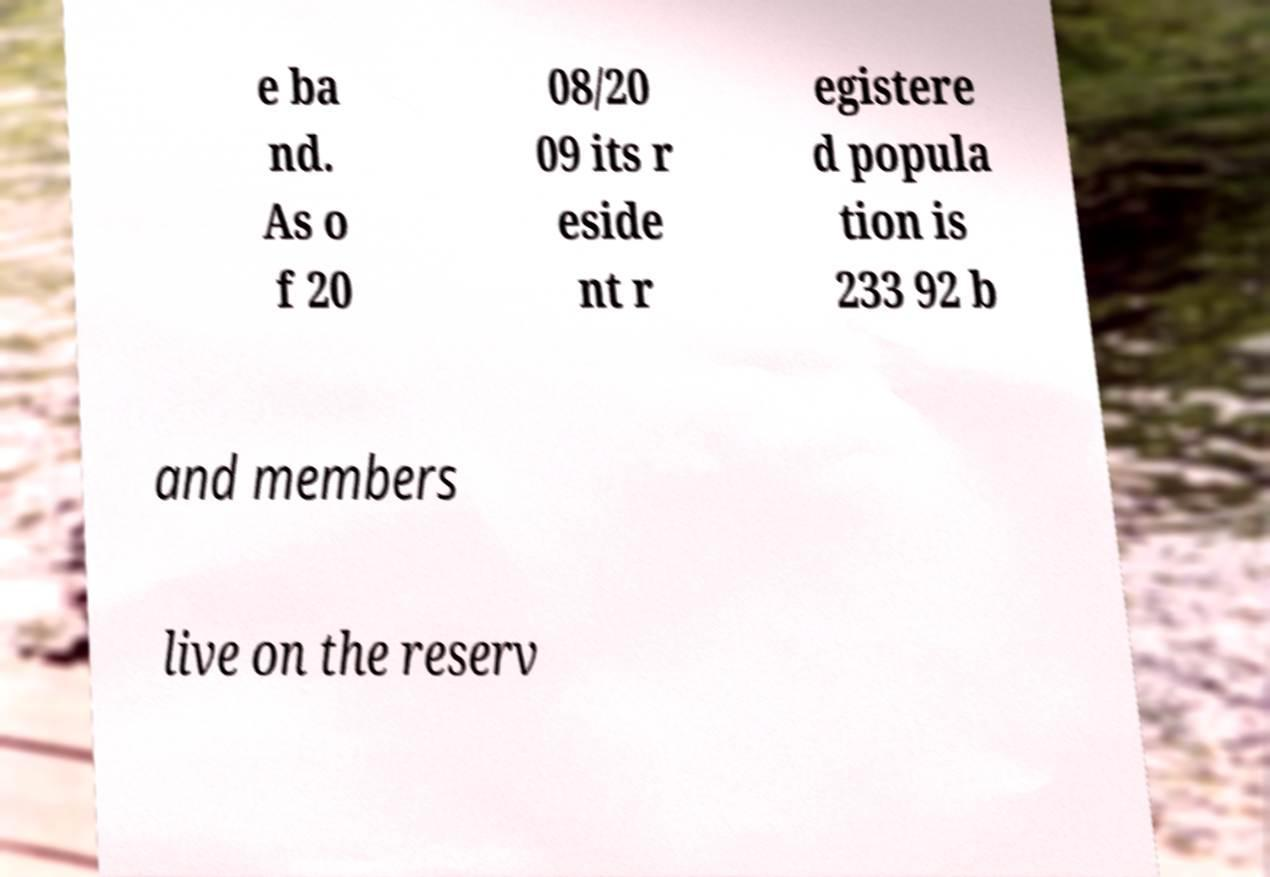Can you accurately transcribe the text from the provided image for me? e ba nd. As o f 20 08/20 09 its r eside nt r egistere d popula tion is 233 92 b and members live on the reserv 